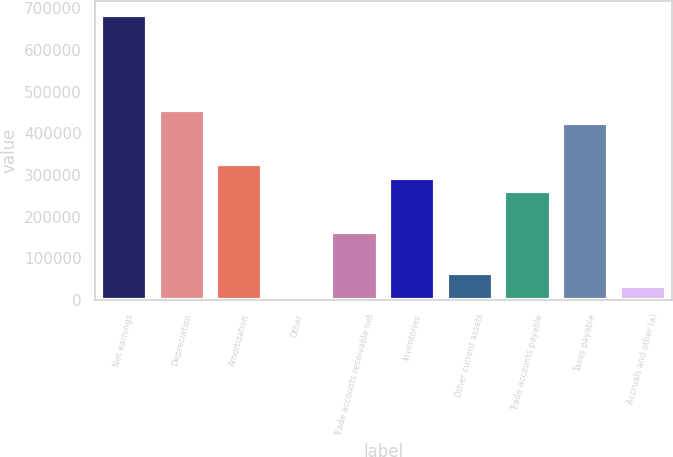Convert chart to OTSL. <chart><loc_0><loc_0><loc_500><loc_500><bar_chart><fcel>Net earnings<fcel>Depreciation<fcel>Amortization<fcel>Other<fcel>Trade accounts receivable net<fcel>Inventories<fcel>Other current assets<fcel>Trade accounts payable<fcel>Taxes payable<fcel>Accruals and other (a)<nl><fcel>684472<fcel>456319<fcel>325946<fcel>13<fcel>162980<fcel>293353<fcel>65199.6<fcel>260759<fcel>423726<fcel>32606.3<nl></chart> 